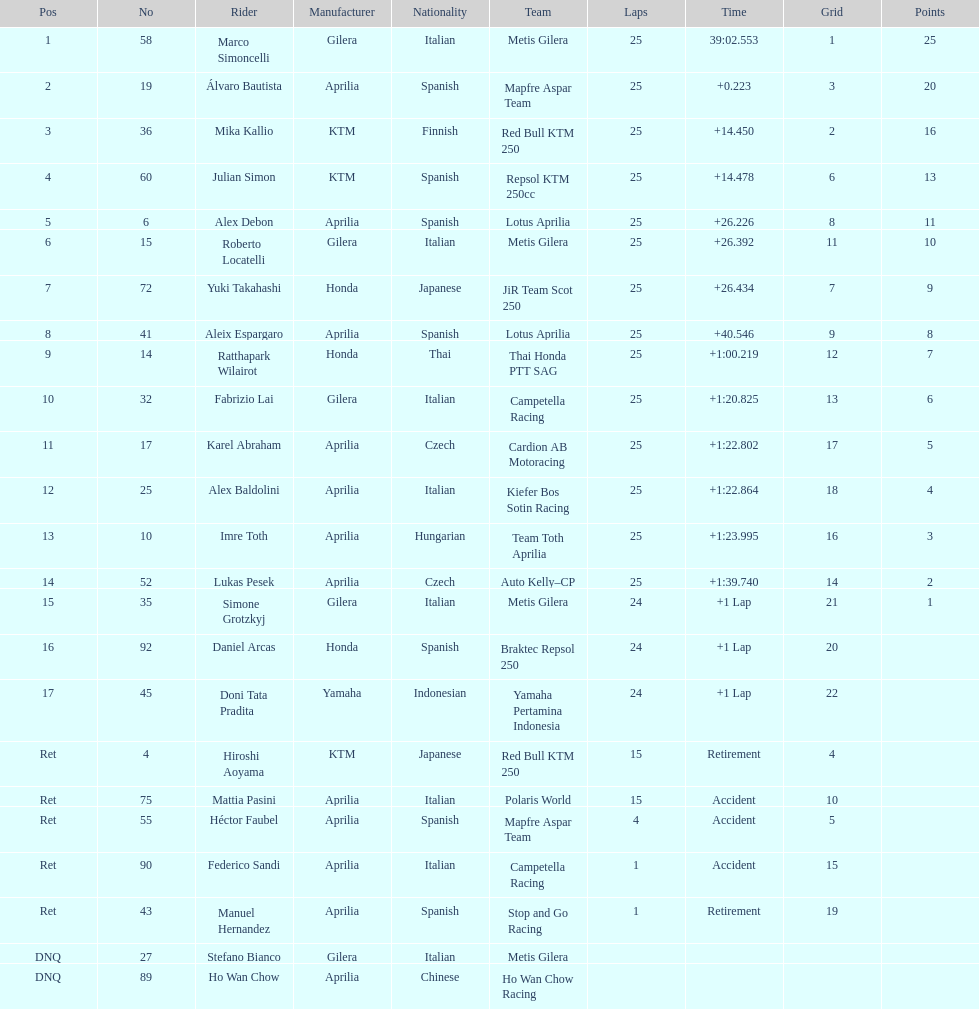Who perfomed the most number of laps, marco simoncelli or hiroshi aoyama? Marco Simoncelli. I'm looking to parse the entire table for insights. Could you assist me with that? {'header': ['Pos', 'No', 'Rider', 'Manufacturer', 'Nationality', 'Team', 'Laps', 'Time', 'Grid', 'Points'], 'rows': [['1', '58', 'Marco Simoncelli', 'Gilera', 'Italian', 'Metis Gilera', '25', '39:02.553', '1', '25'], ['2', '19', 'Álvaro Bautista', 'Aprilia', 'Spanish', 'Mapfre Aspar Team', '25', '+0.223', '3', '20'], ['3', '36', 'Mika Kallio', 'KTM', 'Finnish', 'Red Bull KTM 250', '25', '+14.450', '2', '16'], ['4', '60', 'Julian Simon', 'KTM', 'Spanish', 'Repsol KTM 250cc', '25', '+14.478', '6', '13'], ['5', '6', 'Alex Debon', 'Aprilia', 'Spanish', 'Lotus Aprilia', '25', '+26.226', '8', '11'], ['6', '15', 'Roberto Locatelli', 'Gilera', 'Italian', 'Metis Gilera', '25', '+26.392', '11', '10'], ['7', '72', 'Yuki Takahashi', 'Honda', 'Japanese', 'JiR Team Scot 250', '25', '+26.434', '7', '9'], ['8', '41', 'Aleix Espargaro', 'Aprilia', 'Spanish', 'Lotus Aprilia', '25', '+40.546', '9', '8'], ['9', '14', 'Ratthapark Wilairot', 'Honda', 'Thai', 'Thai Honda PTT SAG', '25', '+1:00.219', '12', '7'], ['10', '32', 'Fabrizio Lai', 'Gilera', 'Italian', 'Campetella Racing', '25', '+1:20.825', '13', '6'], ['11', '17', 'Karel Abraham', 'Aprilia', 'Czech', 'Cardion AB Motoracing', '25', '+1:22.802', '17', '5'], ['12', '25', 'Alex Baldolini', 'Aprilia', 'Italian', 'Kiefer Bos Sotin Racing', '25', '+1:22.864', '18', '4'], ['13', '10', 'Imre Toth', 'Aprilia', 'Hungarian', 'Team Toth Aprilia', '25', '+1:23.995', '16', '3'], ['14', '52', 'Lukas Pesek', 'Aprilia', 'Czech', 'Auto Kelly–CP', '25', '+1:39.740', '14', '2'], ['15', '35', 'Simone Grotzkyj', 'Gilera', 'Italian', 'Metis Gilera', '24', '+1 Lap', '21', '1'], ['16', '92', 'Daniel Arcas', 'Honda', 'Spanish', 'Braktec Repsol 250', '24', '+1 Lap', '20', ''], ['17', '45', 'Doni Tata Pradita', 'Yamaha', 'Indonesian', 'Yamaha Pertamina Indonesia', '24', '+1 Lap', '22', ''], ['Ret', '4', 'Hiroshi Aoyama', 'KTM', 'Japanese', 'Red Bull KTM 250', '15', 'Retirement', '4', ''], ['Ret', '75', 'Mattia Pasini', 'Aprilia', 'Italian', 'Polaris World', '15', 'Accident', '10', ''], ['Ret', '55', 'Héctor Faubel', 'Aprilia', 'Spanish', 'Mapfre Aspar Team', '4', 'Accident', '5', ''], ['Ret', '90', 'Federico Sandi', 'Aprilia', 'Italian', 'Campetella Racing', '1', 'Accident', '15', ''], ['Ret', '43', 'Manuel Hernandez', 'Aprilia', 'Spanish', 'Stop and Go Racing', '1', 'Retirement', '19', ''], ['DNQ', '27', 'Stefano Bianco', 'Gilera', 'Italian', 'Metis Gilera', '', '', '', ''], ['DNQ', '89', 'Ho Wan Chow', 'Aprilia', 'Chinese', 'Ho Wan Chow Racing', '', '', '', '']]} 